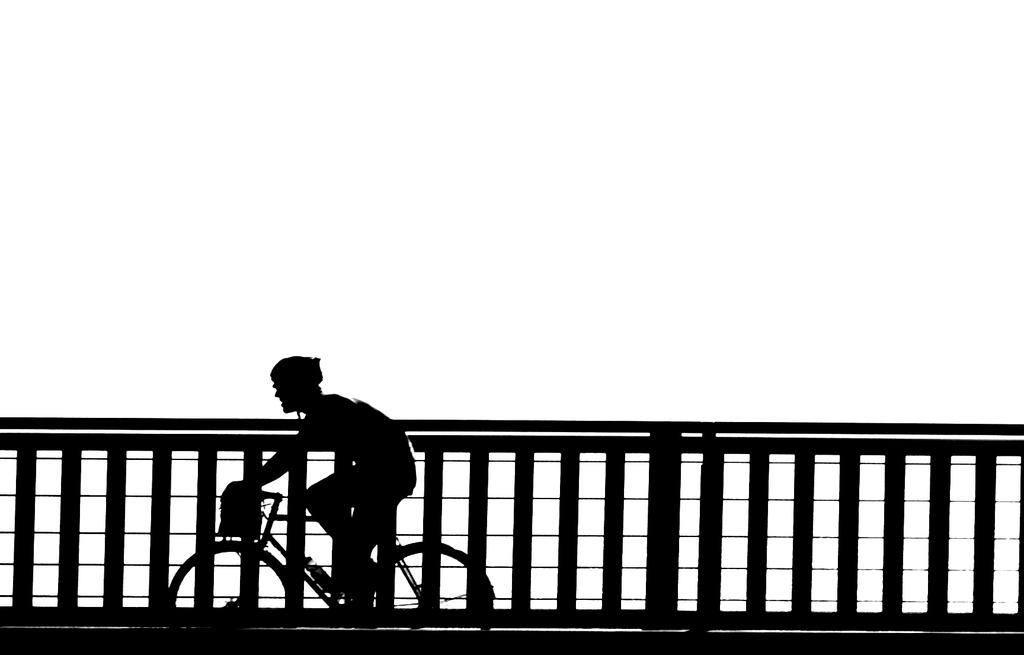What is happening in the image? There is a person in the image, and they are riding a bicycle. Can you describe the surroundings of the person? There is a fence beside the person in the image. What type of action are the cows performing in the image? There are no cows present in the image, so it is not possible to answer that question. 